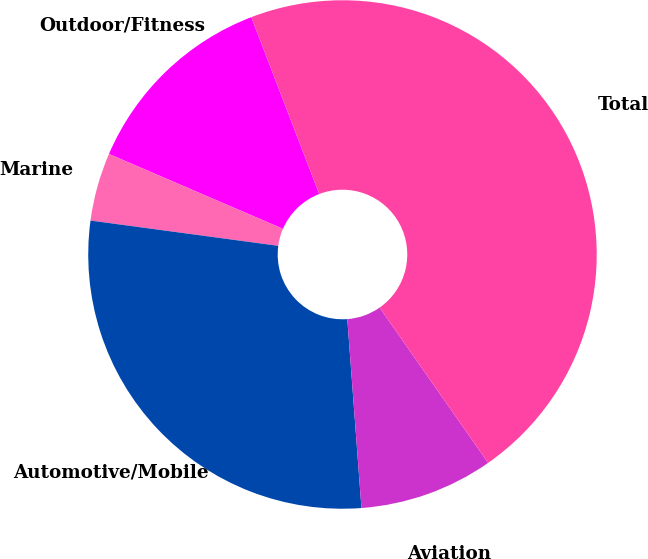Convert chart to OTSL. <chart><loc_0><loc_0><loc_500><loc_500><pie_chart><fcel>Outdoor/Fitness<fcel>Marine<fcel>Automotive/Mobile<fcel>Aviation<fcel>Total<nl><fcel>12.69%<fcel>4.34%<fcel>28.32%<fcel>8.52%<fcel>46.13%<nl></chart> 